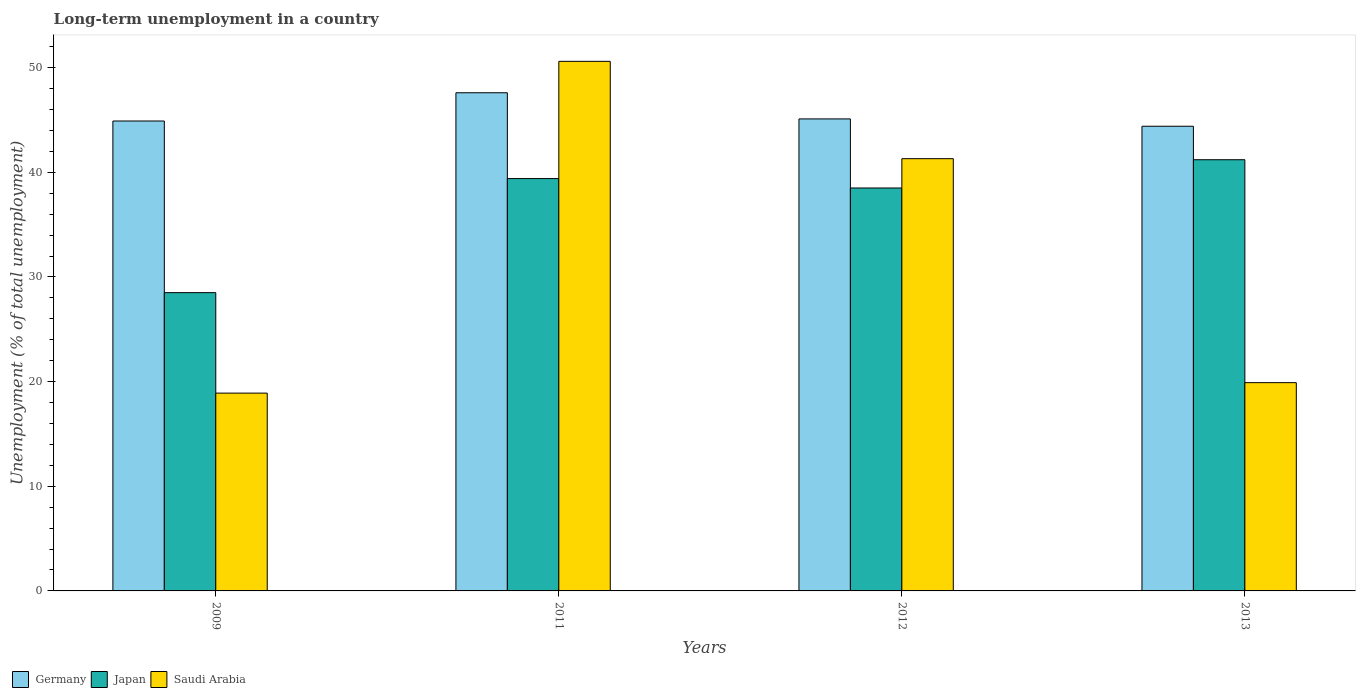How many groups of bars are there?
Give a very brief answer. 4. Are the number of bars per tick equal to the number of legend labels?
Give a very brief answer. Yes. Are the number of bars on each tick of the X-axis equal?
Your answer should be compact. Yes. How many bars are there on the 2nd tick from the right?
Offer a terse response. 3. What is the percentage of long-term unemployed population in Japan in 2012?
Offer a very short reply. 38.5. Across all years, what is the maximum percentage of long-term unemployed population in Japan?
Ensure brevity in your answer.  41.2. Across all years, what is the minimum percentage of long-term unemployed population in Saudi Arabia?
Keep it short and to the point. 18.9. In which year was the percentage of long-term unemployed population in Germany maximum?
Offer a terse response. 2011. What is the total percentage of long-term unemployed population in Germany in the graph?
Your answer should be very brief. 182. What is the difference between the percentage of long-term unemployed population in Germany in 2012 and that in 2013?
Keep it short and to the point. 0.7. What is the difference between the percentage of long-term unemployed population in Saudi Arabia in 2012 and the percentage of long-term unemployed population in Japan in 2013?
Offer a terse response. 0.1. What is the average percentage of long-term unemployed population in Saudi Arabia per year?
Ensure brevity in your answer.  32.67. In the year 2012, what is the difference between the percentage of long-term unemployed population in Germany and percentage of long-term unemployed population in Japan?
Your response must be concise. 6.6. In how many years, is the percentage of long-term unemployed population in Germany greater than 8 %?
Give a very brief answer. 4. What is the ratio of the percentage of long-term unemployed population in Saudi Arabia in 2011 to that in 2012?
Offer a terse response. 1.23. Is the difference between the percentage of long-term unemployed population in Germany in 2012 and 2013 greater than the difference between the percentage of long-term unemployed population in Japan in 2012 and 2013?
Your response must be concise. Yes. What is the difference between the highest and the second highest percentage of long-term unemployed population in Saudi Arabia?
Your answer should be very brief. 9.3. What is the difference between the highest and the lowest percentage of long-term unemployed population in Japan?
Keep it short and to the point. 12.7. In how many years, is the percentage of long-term unemployed population in Saudi Arabia greater than the average percentage of long-term unemployed population in Saudi Arabia taken over all years?
Provide a short and direct response. 2. What does the 1st bar from the left in 2011 represents?
Offer a very short reply. Germany. Is it the case that in every year, the sum of the percentage of long-term unemployed population in Japan and percentage of long-term unemployed population in Saudi Arabia is greater than the percentage of long-term unemployed population in Germany?
Your answer should be very brief. Yes. Are all the bars in the graph horizontal?
Ensure brevity in your answer.  No. How many years are there in the graph?
Keep it short and to the point. 4. What is the difference between two consecutive major ticks on the Y-axis?
Your response must be concise. 10. Are the values on the major ticks of Y-axis written in scientific E-notation?
Offer a terse response. No. Where does the legend appear in the graph?
Provide a short and direct response. Bottom left. How many legend labels are there?
Provide a succinct answer. 3. What is the title of the graph?
Offer a very short reply. Long-term unemployment in a country. Does "Mexico" appear as one of the legend labels in the graph?
Your answer should be very brief. No. What is the label or title of the Y-axis?
Keep it short and to the point. Unemployment (% of total unemployment). What is the Unemployment (% of total unemployment) of Germany in 2009?
Give a very brief answer. 44.9. What is the Unemployment (% of total unemployment) in Japan in 2009?
Ensure brevity in your answer.  28.5. What is the Unemployment (% of total unemployment) in Saudi Arabia in 2009?
Offer a very short reply. 18.9. What is the Unemployment (% of total unemployment) of Germany in 2011?
Offer a very short reply. 47.6. What is the Unemployment (% of total unemployment) of Japan in 2011?
Your answer should be compact. 39.4. What is the Unemployment (% of total unemployment) of Saudi Arabia in 2011?
Your answer should be compact. 50.6. What is the Unemployment (% of total unemployment) of Germany in 2012?
Provide a succinct answer. 45.1. What is the Unemployment (% of total unemployment) in Japan in 2012?
Your answer should be compact. 38.5. What is the Unemployment (% of total unemployment) of Saudi Arabia in 2012?
Make the answer very short. 41.3. What is the Unemployment (% of total unemployment) in Germany in 2013?
Your answer should be compact. 44.4. What is the Unemployment (% of total unemployment) in Japan in 2013?
Provide a short and direct response. 41.2. What is the Unemployment (% of total unemployment) of Saudi Arabia in 2013?
Offer a very short reply. 19.9. Across all years, what is the maximum Unemployment (% of total unemployment) of Germany?
Give a very brief answer. 47.6. Across all years, what is the maximum Unemployment (% of total unemployment) in Japan?
Offer a very short reply. 41.2. Across all years, what is the maximum Unemployment (% of total unemployment) of Saudi Arabia?
Provide a short and direct response. 50.6. Across all years, what is the minimum Unemployment (% of total unemployment) of Germany?
Your response must be concise. 44.4. Across all years, what is the minimum Unemployment (% of total unemployment) of Saudi Arabia?
Ensure brevity in your answer.  18.9. What is the total Unemployment (% of total unemployment) of Germany in the graph?
Offer a very short reply. 182. What is the total Unemployment (% of total unemployment) of Japan in the graph?
Your response must be concise. 147.6. What is the total Unemployment (% of total unemployment) of Saudi Arabia in the graph?
Offer a terse response. 130.7. What is the difference between the Unemployment (% of total unemployment) in Germany in 2009 and that in 2011?
Provide a succinct answer. -2.7. What is the difference between the Unemployment (% of total unemployment) in Japan in 2009 and that in 2011?
Give a very brief answer. -10.9. What is the difference between the Unemployment (% of total unemployment) of Saudi Arabia in 2009 and that in 2011?
Make the answer very short. -31.7. What is the difference between the Unemployment (% of total unemployment) of Saudi Arabia in 2009 and that in 2012?
Your answer should be compact. -22.4. What is the difference between the Unemployment (% of total unemployment) of Japan in 2009 and that in 2013?
Ensure brevity in your answer.  -12.7. What is the difference between the Unemployment (% of total unemployment) of Germany in 2011 and that in 2012?
Your answer should be very brief. 2.5. What is the difference between the Unemployment (% of total unemployment) of Japan in 2011 and that in 2012?
Provide a succinct answer. 0.9. What is the difference between the Unemployment (% of total unemployment) in Saudi Arabia in 2011 and that in 2012?
Provide a succinct answer. 9.3. What is the difference between the Unemployment (% of total unemployment) of Germany in 2011 and that in 2013?
Make the answer very short. 3.2. What is the difference between the Unemployment (% of total unemployment) of Saudi Arabia in 2011 and that in 2013?
Keep it short and to the point. 30.7. What is the difference between the Unemployment (% of total unemployment) of Germany in 2012 and that in 2013?
Your answer should be very brief. 0.7. What is the difference between the Unemployment (% of total unemployment) of Saudi Arabia in 2012 and that in 2013?
Make the answer very short. 21.4. What is the difference between the Unemployment (% of total unemployment) of Germany in 2009 and the Unemployment (% of total unemployment) of Saudi Arabia in 2011?
Ensure brevity in your answer.  -5.7. What is the difference between the Unemployment (% of total unemployment) in Japan in 2009 and the Unemployment (% of total unemployment) in Saudi Arabia in 2011?
Provide a short and direct response. -22.1. What is the difference between the Unemployment (% of total unemployment) in Germany in 2009 and the Unemployment (% of total unemployment) in Japan in 2012?
Keep it short and to the point. 6.4. What is the difference between the Unemployment (% of total unemployment) in Germany in 2009 and the Unemployment (% of total unemployment) in Saudi Arabia in 2012?
Ensure brevity in your answer.  3.6. What is the difference between the Unemployment (% of total unemployment) in Germany in 2011 and the Unemployment (% of total unemployment) in Saudi Arabia in 2012?
Offer a very short reply. 6.3. What is the difference between the Unemployment (% of total unemployment) of Germany in 2011 and the Unemployment (% of total unemployment) of Japan in 2013?
Keep it short and to the point. 6.4. What is the difference between the Unemployment (% of total unemployment) of Germany in 2011 and the Unemployment (% of total unemployment) of Saudi Arabia in 2013?
Provide a short and direct response. 27.7. What is the difference between the Unemployment (% of total unemployment) of Germany in 2012 and the Unemployment (% of total unemployment) of Japan in 2013?
Ensure brevity in your answer.  3.9. What is the difference between the Unemployment (% of total unemployment) in Germany in 2012 and the Unemployment (% of total unemployment) in Saudi Arabia in 2013?
Ensure brevity in your answer.  25.2. What is the difference between the Unemployment (% of total unemployment) in Japan in 2012 and the Unemployment (% of total unemployment) in Saudi Arabia in 2013?
Ensure brevity in your answer.  18.6. What is the average Unemployment (% of total unemployment) in Germany per year?
Give a very brief answer. 45.5. What is the average Unemployment (% of total unemployment) in Japan per year?
Make the answer very short. 36.9. What is the average Unemployment (% of total unemployment) in Saudi Arabia per year?
Your answer should be very brief. 32.67. In the year 2009, what is the difference between the Unemployment (% of total unemployment) in Germany and Unemployment (% of total unemployment) in Japan?
Your answer should be very brief. 16.4. In the year 2011, what is the difference between the Unemployment (% of total unemployment) in Germany and Unemployment (% of total unemployment) in Saudi Arabia?
Make the answer very short. -3. In the year 2011, what is the difference between the Unemployment (% of total unemployment) in Japan and Unemployment (% of total unemployment) in Saudi Arabia?
Provide a short and direct response. -11.2. In the year 2012, what is the difference between the Unemployment (% of total unemployment) of Germany and Unemployment (% of total unemployment) of Japan?
Offer a very short reply. 6.6. In the year 2012, what is the difference between the Unemployment (% of total unemployment) of Germany and Unemployment (% of total unemployment) of Saudi Arabia?
Keep it short and to the point. 3.8. In the year 2012, what is the difference between the Unemployment (% of total unemployment) in Japan and Unemployment (% of total unemployment) in Saudi Arabia?
Offer a terse response. -2.8. In the year 2013, what is the difference between the Unemployment (% of total unemployment) in Germany and Unemployment (% of total unemployment) in Japan?
Give a very brief answer. 3.2. In the year 2013, what is the difference between the Unemployment (% of total unemployment) in Germany and Unemployment (% of total unemployment) in Saudi Arabia?
Your answer should be very brief. 24.5. In the year 2013, what is the difference between the Unemployment (% of total unemployment) in Japan and Unemployment (% of total unemployment) in Saudi Arabia?
Provide a succinct answer. 21.3. What is the ratio of the Unemployment (% of total unemployment) of Germany in 2009 to that in 2011?
Make the answer very short. 0.94. What is the ratio of the Unemployment (% of total unemployment) in Japan in 2009 to that in 2011?
Your answer should be very brief. 0.72. What is the ratio of the Unemployment (% of total unemployment) in Saudi Arabia in 2009 to that in 2011?
Offer a very short reply. 0.37. What is the ratio of the Unemployment (% of total unemployment) of Germany in 2009 to that in 2012?
Make the answer very short. 1. What is the ratio of the Unemployment (% of total unemployment) in Japan in 2009 to that in 2012?
Ensure brevity in your answer.  0.74. What is the ratio of the Unemployment (% of total unemployment) of Saudi Arabia in 2009 to that in 2012?
Ensure brevity in your answer.  0.46. What is the ratio of the Unemployment (% of total unemployment) of Germany in 2009 to that in 2013?
Offer a terse response. 1.01. What is the ratio of the Unemployment (% of total unemployment) in Japan in 2009 to that in 2013?
Provide a succinct answer. 0.69. What is the ratio of the Unemployment (% of total unemployment) in Saudi Arabia in 2009 to that in 2013?
Ensure brevity in your answer.  0.95. What is the ratio of the Unemployment (% of total unemployment) of Germany in 2011 to that in 2012?
Provide a short and direct response. 1.06. What is the ratio of the Unemployment (% of total unemployment) of Japan in 2011 to that in 2012?
Offer a terse response. 1.02. What is the ratio of the Unemployment (% of total unemployment) of Saudi Arabia in 2011 to that in 2012?
Provide a succinct answer. 1.23. What is the ratio of the Unemployment (% of total unemployment) in Germany in 2011 to that in 2013?
Keep it short and to the point. 1.07. What is the ratio of the Unemployment (% of total unemployment) in Japan in 2011 to that in 2013?
Provide a succinct answer. 0.96. What is the ratio of the Unemployment (% of total unemployment) in Saudi Arabia in 2011 to that in 2013?
Offer a very short reply. 2.54. What is the ratio of the Unemployment (% of total unemployment) of Germany in 2012 to that in 2013?
Offer a very short reply. 1.02. What is the ratio of the Unemployment (% of total unemployment) in Japan in 2012 to that in 2013?
Give a very brief answer. 0.93. What is the ratio of the Unemployment (% of total unemployment) of Saudi Arabia in 2012 to that in 2013?
Provide a short and direct response. 2.08. What is the difference between the highest and the second highest Unemployment (% of total unemployment) of Japan?
Give a very brief answer. 1.8. What is the difference between the highest and the second highest Unemployment (% of total unemployment) of Saudi Arabia?
Offer a terse response. 9.3. What is the difference between the highest and the lowest Unemployment (% of total unemployment) of Japan?
Your response must be concise. 12.7. What is the difference between the highest and the lowest Unemployment (% of total unemployment) in Saudi Arabia?
Ensure brevity in your answer.  31.7. 